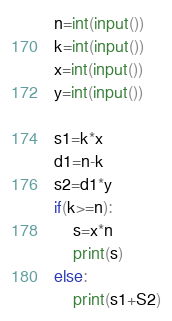<code> <loc_0><loc_0><loc_500><loc_500><_Python_>n=int(input())
k=int(input())
x=int(input())
y=int(input())

s1=k*x
d1=n-k
s2=d1*y
if(k>=n):
    s=x*n
    print(s)
else:
    print(s1+S2)
</code> 